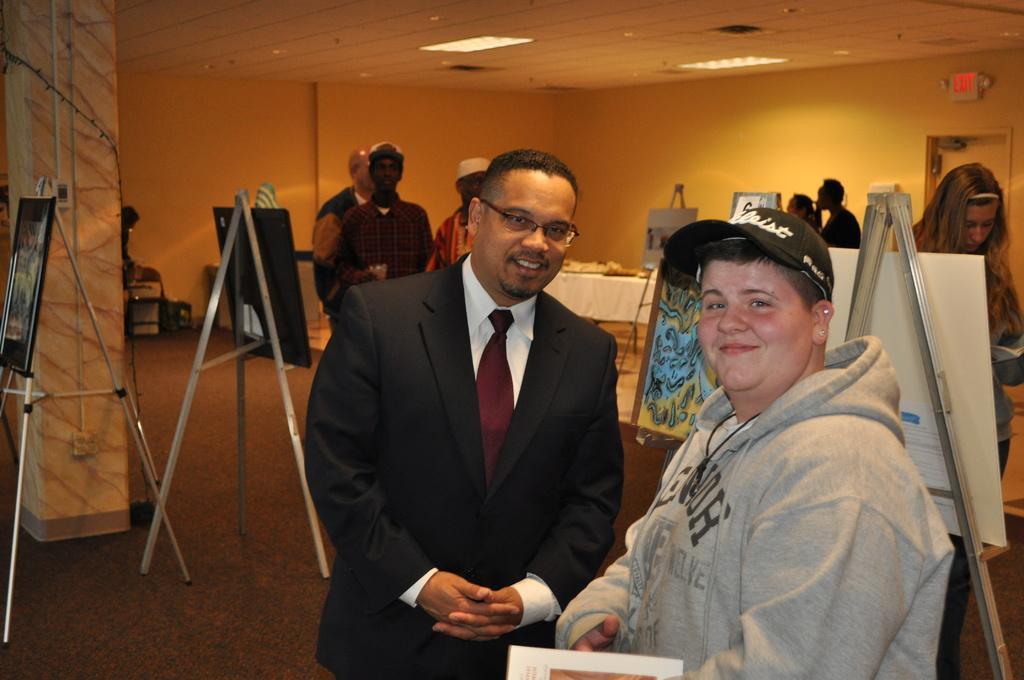Describe this image in one or two sentences. In this image I can see a person wearing ash colored dress and a person wearing black blazer and white shirt are standing and smiling. In the background I can see few persons standing, few painting boards, the wall, the ceiling, the door, a pillar and few lights to the ceiling. 